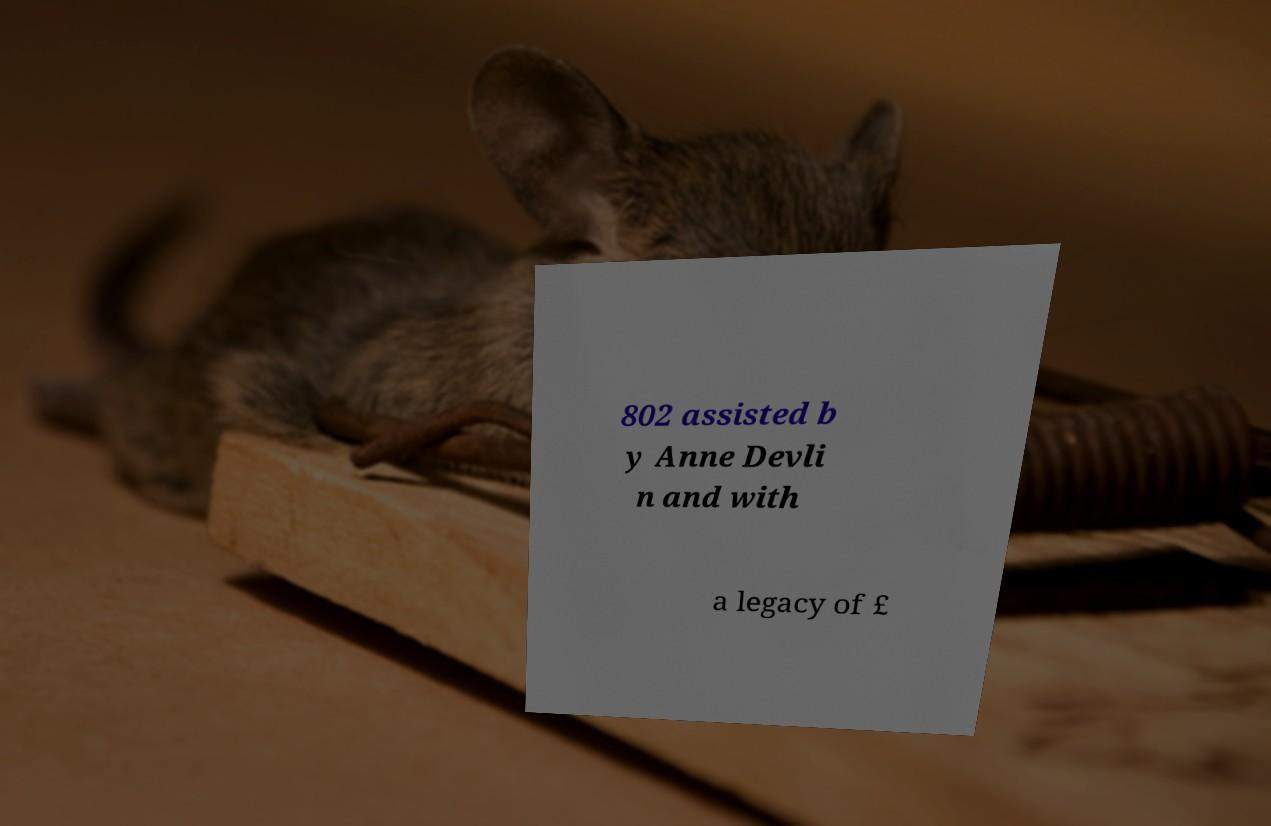Can you read and provide the text displayed in the image?This photo seems to have some interesting text. Can you extract and type it out for me? 802 assisted b y Anne Devli n and with a legacy of £ 